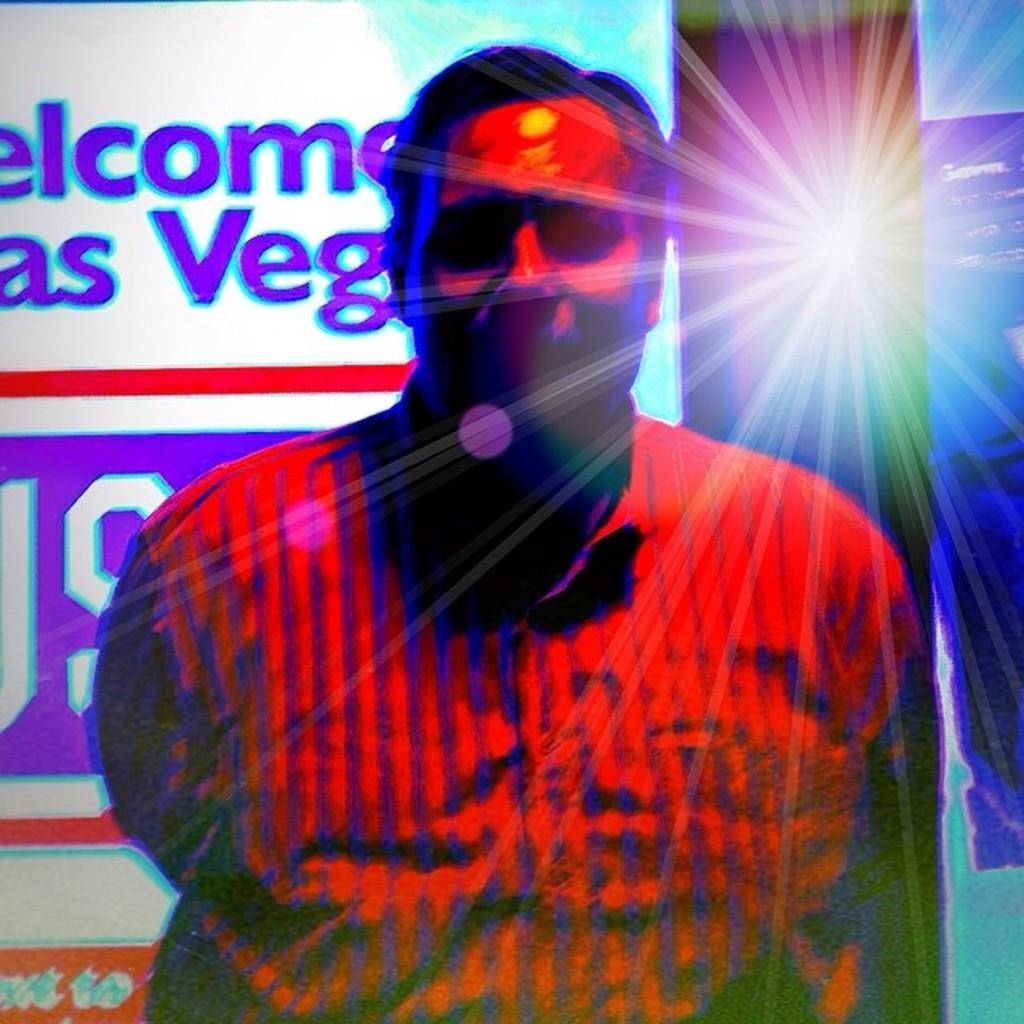What is the main subject of the image? There is a man standing in the image. What is the man wearing? The man is wearing a shirt. What can be seen in the background of the image? There is a banner in the background of the image. What is the source of light in the image? Light rays are visible in the image. What type of thing is the man trying to move with his mind in the image? There is no indication in the image that the man is trying to move anything with his mind. 